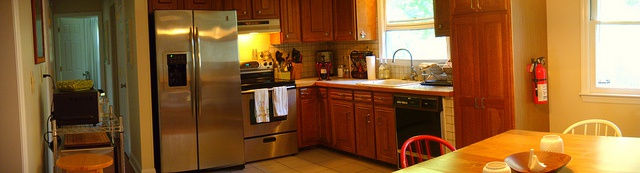Describe the objects in this image and their specific colors. I can see refrigerator in maroon, olive, and black tones, dining table in maroon, orange, red, lightyellow, and khaki tones, oven in maroon, black, and darkgray tones, microwave in maroon, black, and olive tones, and bowl in maroon, red, and orange tones in this image. 